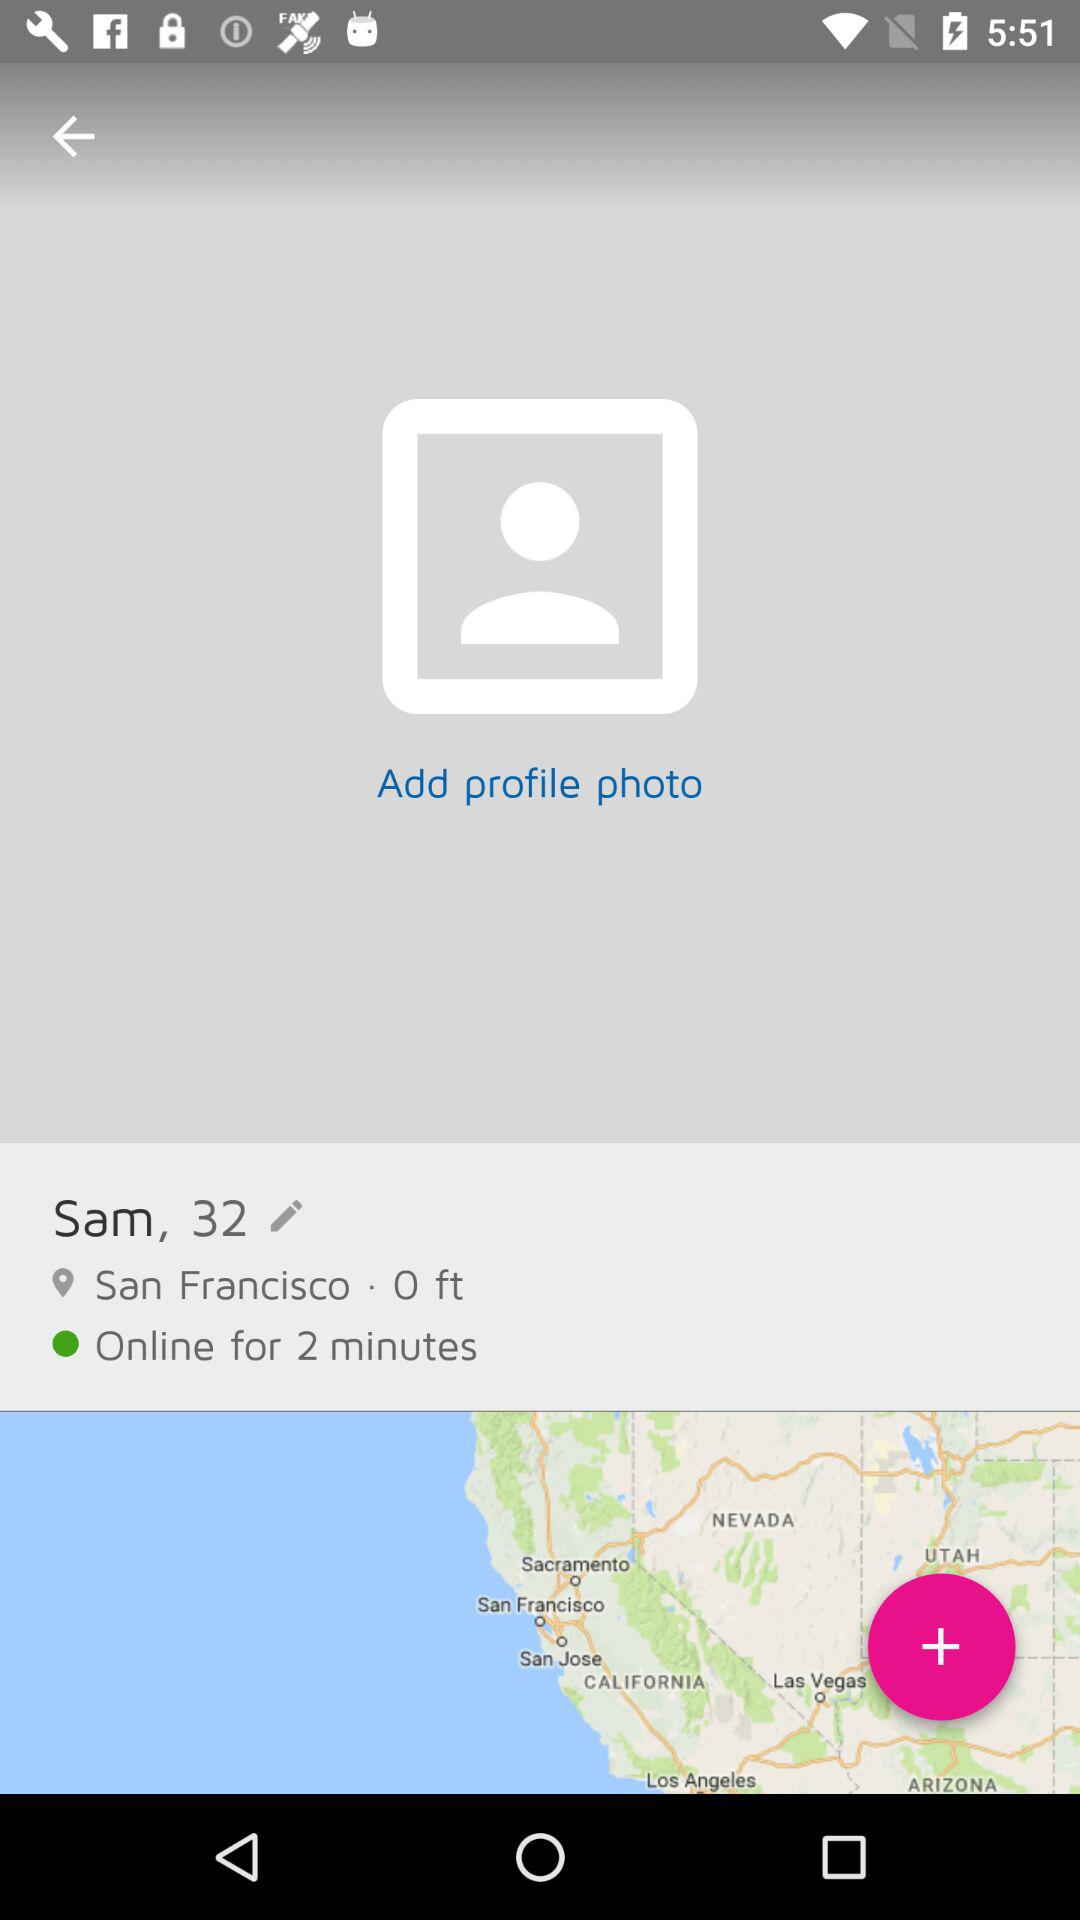What is the user name? The user name is Sam. 